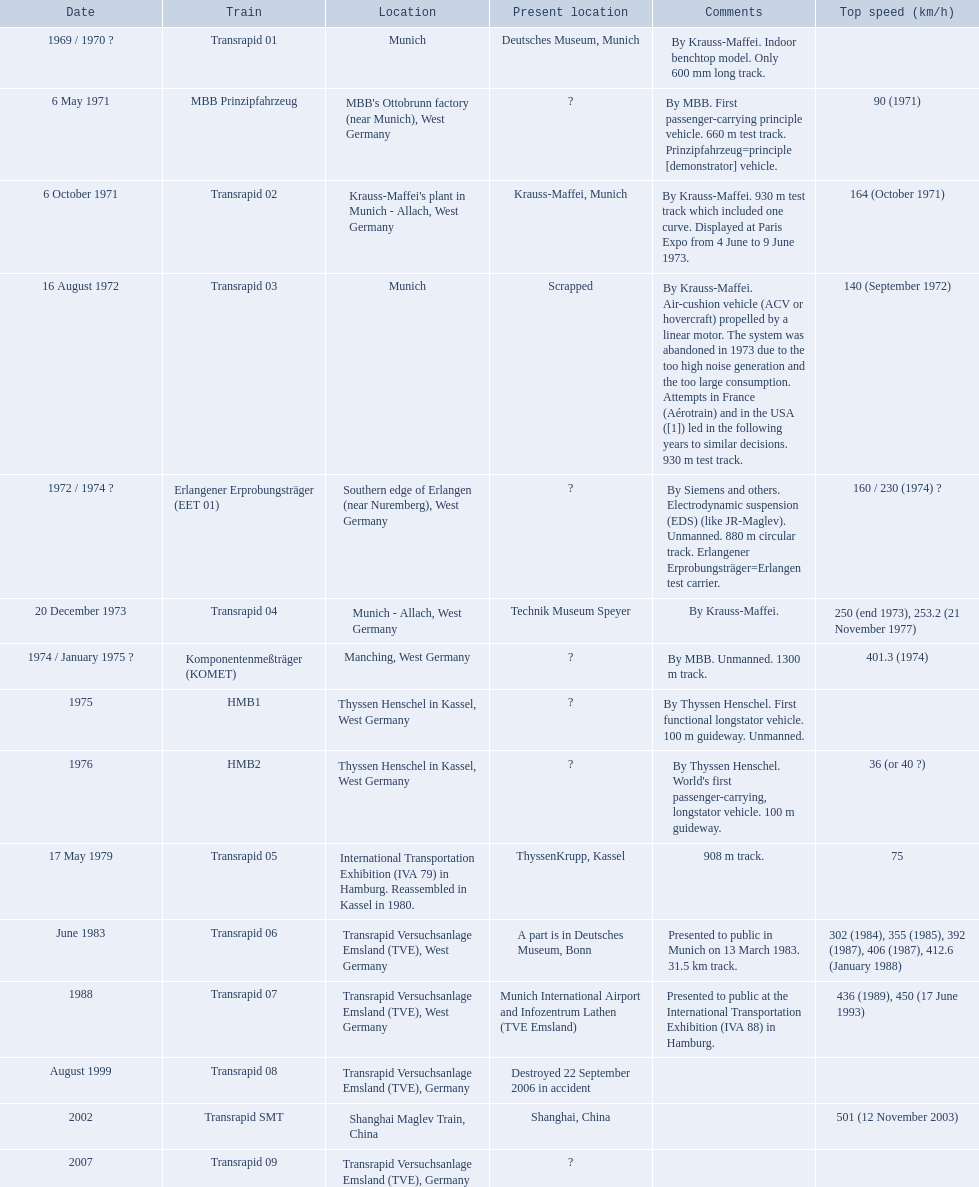Could you parse the entire table as a dict? {'header': ['Date', 'Train', 'Location', 'Present location', 'Comments', 'Top speed (km/h)'], 'rows': [['1969 / 1970\xa0?', 'Transrapid 01', 'Munich', 'Deutsches Museum, Munich', 'By Krauss-Maffei. Indoor benchtop model. Only 600\xa0mm long track.', ''], ['6 May 1971', 'MBB Prinzipfahrzeug', "MBB's Ottobrunn factory (near Munich), West Germany", '?', 'By MBB. First passenger-carrying principle vehicle. 660 m test track. Prinzipfahrzeug=principle [demonstrator] vehicle.', '90 (1971)'], ['6 October 1971', 'Transrapid 02', "Krauss-Maffei's plant in Munich - Allach, West Germany", 'Krauss-Maffei, Munich', 'By Krauss-Maffei. 930 m test track which included one curve. Displayed at Paris Expo from 4 June to 9 June 1973.', '164 (October 1971)'], ['16 August 1972', 'Transrapid 03', 'Munich', 'Scrapped', 'By Krauss-Maffei. Air-cushion vehicle (ACV or hovercraft) propelled by a linear motor. The system was abandoned in 1973 due to the too high noise generation and the too large consumption. Attempts in France (Aérotrain) and in the USA ([1]) led in the following years to similar decisions. 930 m test track.', '140 (September 1972)'], ['1972 / 1974\xa0?', 'Erlangener Erprobungsträger (EET 01)', 'Southern edge of Erlangen (near Nuremberg), West Germany', '?', 'By Siemens and others. Electrodynamic suspension (EDS) (like JR-Maglev). Unmanned. 880 m circular track. Erlangener Erprobungsträger=Erlangen test carrier.', '160 / 230 (1974)\xa0?'], ['20 December 1973', 'Transrapid 04', 'Munich - Allach, West Germany', 'Technik Museum Speyer', 'By Krauss-Maffei.', '250 (end 1973), 253.2 (21 November 1977)'], ['1974 / January 1975\xa0?', 'Komponentenmeßträger (KOMET)', 'Manching, West Germany', '?', 'By MBB. Unmanned. 1300 m track.', '401.3 (1974)'], ['1975', 'HMB1', 'Thyssen Henschel in Kassel, West Germany', '?', 'By Thyssen Henschel. First functional longstator vehicle. 100 m guideway. Unmanned.', ''], ['1976', 'HMB2', 'Thyssen Henschel in Kassel, West Germany', '?', "By Thyssen Henschel. World's first passenger-carrying, longstator vehicle. 100 m guideway.", '36 (or 40\xa0?)'], ['17 May 1979', 'Transrapid 05', 'International Transportation Exhibition (IVA 79) in Hamburg. Reassembled in Kassel in 1980.', 'ThyssenKrupp, Kassel', '908 m track.', '75'], ['June 1983', 'Transrapid 06', 'Transrapid Versuchsanlage Emsland (TVE), West Germany', 'A part is in Deutsches Museum, Bonn', 'Presented to public in Munich on 13 March 1983. 31.5\xa0km track.', '302 (1984), 355 (1985), 392 (1987), 406 (1987), 412.6 (January 1988)'], ['1988', 'Transrapid 07', 'Transrapid Versuchsanlage Emsland (TVE), West Germany', 'Munich International Airport and Infozentrum Lathen (TVE Emsland)', 'Presented to public at the International Transportation Exhibition (IVA 88) in Hamburg.', '436 (1989), 450 (17 June 1993)'], ['August 1999', 'Transrapid 08', 'Transrapid Versuchsanlage Emsland (TVE), Germany', 'Destroyed 22 September 2006 in accident', '', ''], ['2002', 'Transrapid SMT', 'Shanghai Maglev Train, China', 'Shanghai, China', '', '501 (12 November 2003)'], ['2007', 'Transrapid 09', 'Transrapid Versuchsanlage Emsland (TVE), Germany', '?', '', '']]} Which trains had a top speed listed? MBB Prinzipfahrzeug, Transrapid 02, Transrapid 03, Erlangener Erprobungsträger (EET 01), Transrapid 04, Komponentenmeßträger (KOMET), HMB2, Transrapid 05, Transrapid 06, Transrapid 07, Transrapid SMT. Which ones list munich as a location? MBB Prinzipfahrzeug, Transrapid 02, Transrapid 03. Of these which ones present location is known? Transrapid 02, Transrapid 03. Which of those is no longer in operation? Transrapid 03. What is the greatest speed achieved by any trains presented here? 501 (12 November 2003). What train has hit a top speed of 501? Transrapid SMT. 